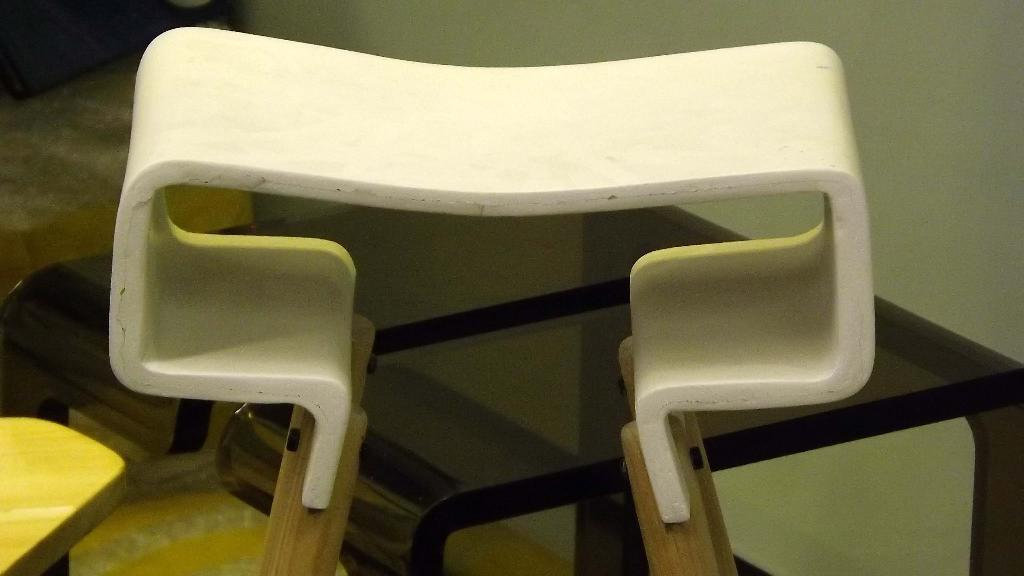What is the color of the main object in the image? The main object in the image is white. What might the object be used for? The object may be a table, which is typically used for placing items or serving food. What type of vest is visible on the table in the image? There is no vest present in the image; it only features a white object that may be a table. 